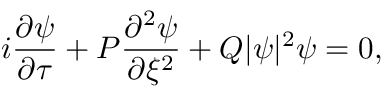<formula> <loc_0><loc_0><loc_500><loc_500>i \frac { \partial \psi } { \partial \tau } + P \frac { \partial ^ { 2 } \psi } { \partial \xi ^ { 2 } } + Q | \psi | ^ { 2 } \psi = 0 ,</formula> 